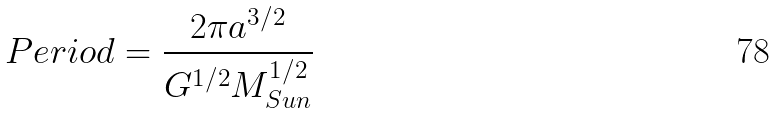<formula> <loc_0><loc_0><loc_500><loc_500>P e r i o d = \frac { 2 \pi a ^ { 3 / 2 } } { G ^ { 1 / 2 } M _ { S u n } ^ { 1 / 2 } }</formula> 